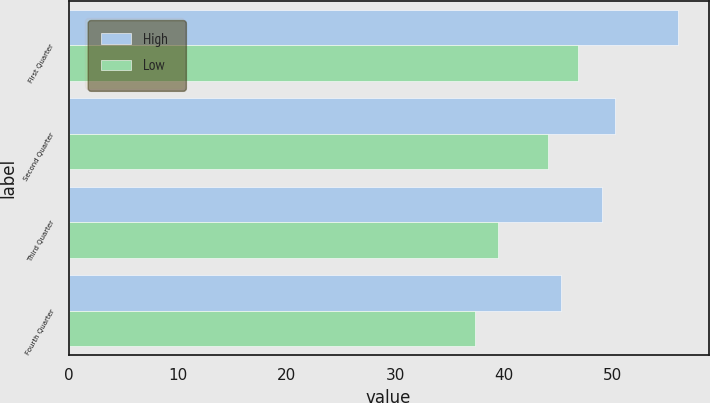Convert chart. <chart><loc_0><loc_0><loc_500><loc_500><stacked_bar_chart><ecel><fcel>First Quarter<fcel>Second Quarter<fcel>Third Quarter<fcel>Fourth Quarter<nl><fcel>High<fcel>56<fcel>50.21<fcel>49.04<fcel>45.23<nl><fcel>Low<fcel>46.77<fcel>44.01<fcel>39.45<fcel>37.3<nl></chart> 